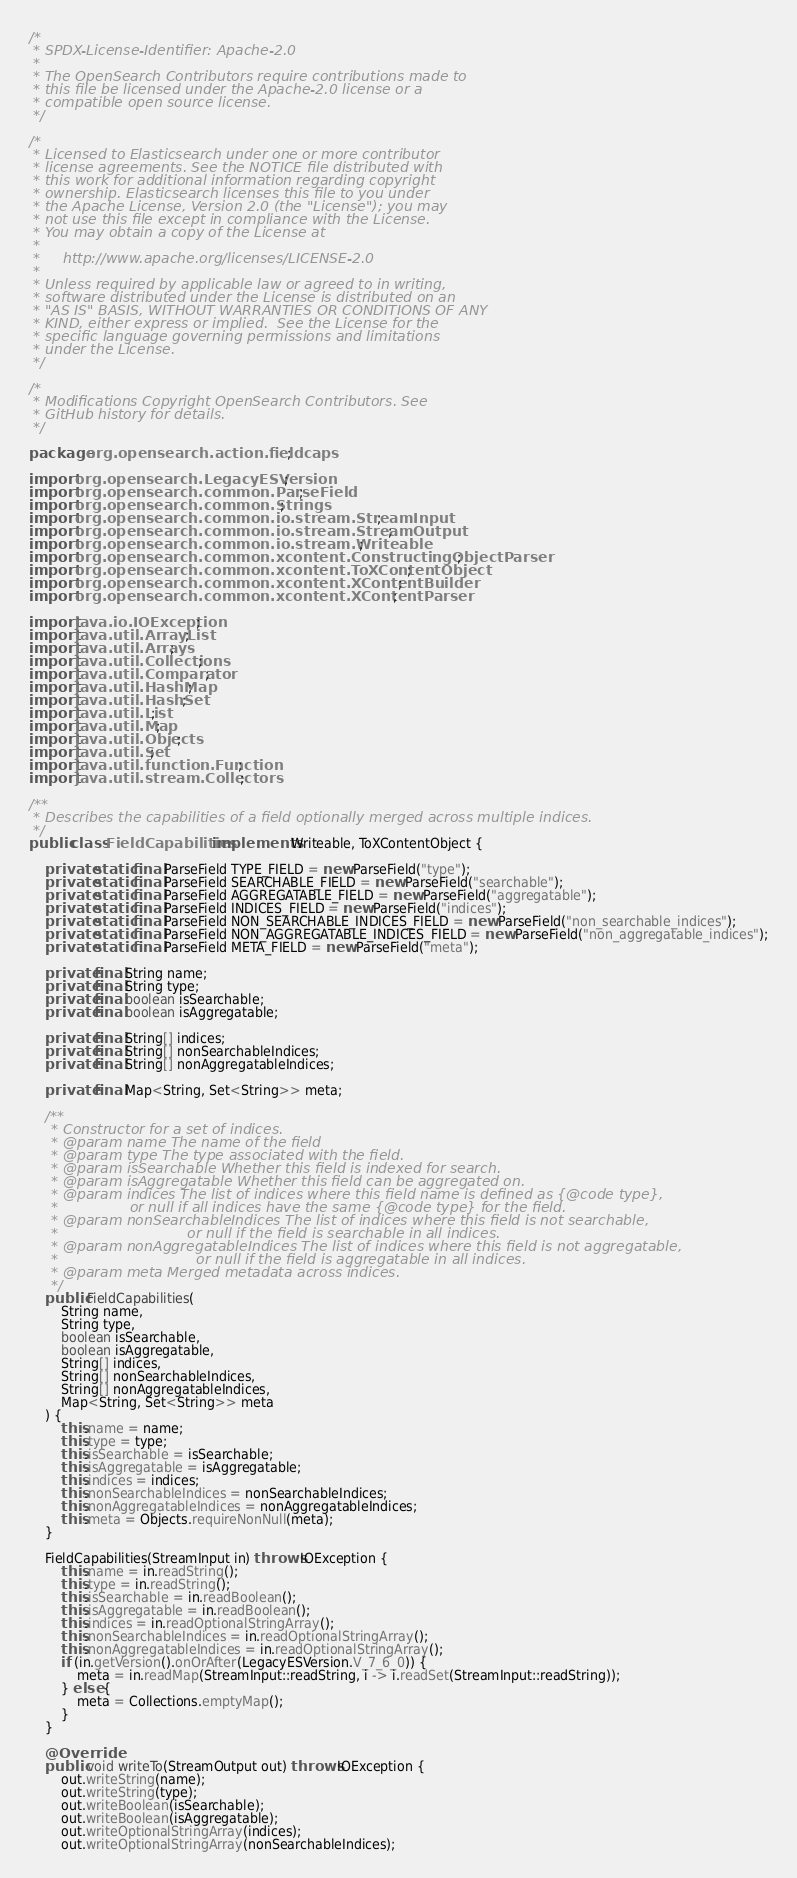<code> <loc_0><loc_0><loc_500><loc_500><_Java_>/*
 * SPDX-License-Identifier: Apache-2.0
 *
 * The OpenSearch Contributors require contributions made to
 * this file be licensed under the Apache-2.0 license or a
 * compatible open source license.
 */

/*
 * Licensed to Elasticsearch under one or more contributor
 * license agreements. See the NOTICE file distributed with
 * this work for additional information regarding copyright
 * ownership. Elasticsearch licenses this file to you under
 * the Apache License, Version 2.0 (the "License"); you may
 * not use this file except in compliance with the License.
 * You may obtain a copy of the License at
 *
 *     http://www.apache.org/licenses/LICENSE-2.0
 *
 * Unless required by applicable law or agreed to in writing,
 * software distributed under the License is distributed on an
 * "AS IS" BASIS, WITHOUT WARRANTIES OR CONDITIONS OF ANY
 * KIND, either express or implied.  See the License for the
 * specific language governing permissions and limitations
 * under the License.
 */

/*
 * Modifications Copyright OpenSearch Contributors. See
 * GitHub history for details.
 */

package org.opensearch.action.fieldcaps;

import org.opensearch.LegacyESVersion;
import org.opensearch.common.ParseField;
import org.opensearch.common.Strings;
import org.opensearch.common.io.stream.StreamInput;
import org.opensearch.common.io.stream.StreamOutput;
import org.opensearch.common.io.stream.Writeable;
import org.opensearch.common.xcontent.ConstructingObjectParser;
import org.opensearch.common.xcontent.ToXContentObject;
import org.opensearch.common.xcontent.XContentBuilder;
import org.opensearch.common.xcontent.XContentParser;

import java.io.IOException;
import java.util.ArrayList;
import java.util.Arrays;
import java.util.Collections;
import java.util.Comparator;
import java.util.HashMap;
import java.util.HashSet;
import java.util.List;
import java.util.Map;
import java.util.Objects;
import java.util.Set;
import java.util.function.Function;
import java.util.stream.Collectors;

/**
 * Describes the capabilities of a field optionally merged across multiple indices.
 */
public class FieldCapabilities implements Writeable, ToXContentObject {

    private static final ParseField TYPE_FIELD = new ParseField("type");
    private static final ParseField SEARCHABLE_FIELD = new ParseField("searchable");
    private static final ParseField AGGREGATABLE_FIELD = new ParseField("aggregatable");
    private static final ParseField INDICES_FIELD = new ParseField("indices");
    private static final ParseField NON_SEARCHABLE_INDICES_FIELD = new ParseField("non_searchable_indices");
    private static final ParseField NON_AGGREGATABLE_INDICES_FIELD = new ParseField("non_aggregatable_indices");
    private static final ParseField META_FIELD = new ParseField("meta");

    private final String name;
    private final String type;
    private final boolean isSearchable;
    private final boolean isAggregatable;

    private final String[] indices;
    private final String[] nonSearchableIndices;
    private final String[] nonAggregatableIndices;

    private final Map<String, Set<String>> meta;

    /**
     * Constructor for a set of indices.
     * @param name The name of the field
     * @param type The type associated with the field.
     * @param isSearchable Whether this field is indexed for search.
     * @param isAggregatable Whether this field can be aggregated on.
     * @param indices The list of indices where this field name is defined as {@code type},
     *                or null if all indices have the same {@code type} for the field.
     * @param nonSearchableIndices The list of indices where this field is not searchable,
     *                             or null if the field is searchable in all indices.
     * @param nonAggregatableIndices The list of indices where this field is not aggregatable,
     *                               or null if the field is aggregatable in all indices.
     * @param meta Merged metadata across indices.
     */
    public FieldCapabilities(
        String name,
        String type,
        boolean isSearchable,
        boolean isAggregatable,
        String[] indices,
        String[] nonSearchableIndices,
        String[] nonAggregatableIndices,
        Map<String, Set<String>> meta
    ) {
        this.name = name;
        this.type = type;
        this.isSearchable = isSearchable;
        this.isAggregatable = isAggregatable;
        this.indices = indices;
        this.nonSearchableIndices = nonSearchableIndices;
        this.nonAggregatableIndices = nonAggregatableIndices;
        this.meta = Objects.requireNonNull(meta);
    }

    FieldCapabilities(StreamInput in) throws IOException {
        this.name = in.readString();
        this.type = in.readString();
        this.isSearchable = in.readBoolean();
        this.isAggregatable = in.readBoolean();
        this.indices = in.readOptionalStringArray();
        this.nonSearchableIndices = in.readOptionalStringArray();
        this.nonAggregatableIndices = in.readOptionalStringArray();
        if (in.getVersion().onOrAfter(LegacyESVersion.V_7_6_0)) {
            meta = in.readMap(StreamInput::readString, i -> i.readSet(StreamInput::readString));
        } else {
            meta = Collections.emptyMap();
        }
    }

    @Override
    public void writeTo(StreamOutput out) throws IOException {
        out.writeString(name);
        out.writeString(type);
        out.writeBoolean(isSearchable);
        out.writeBoolean(isAggregatable);
        out.writeOptionalStringArray(indices);
        out.writeOptionalStringArray(nonSearchableIndices);</code> 